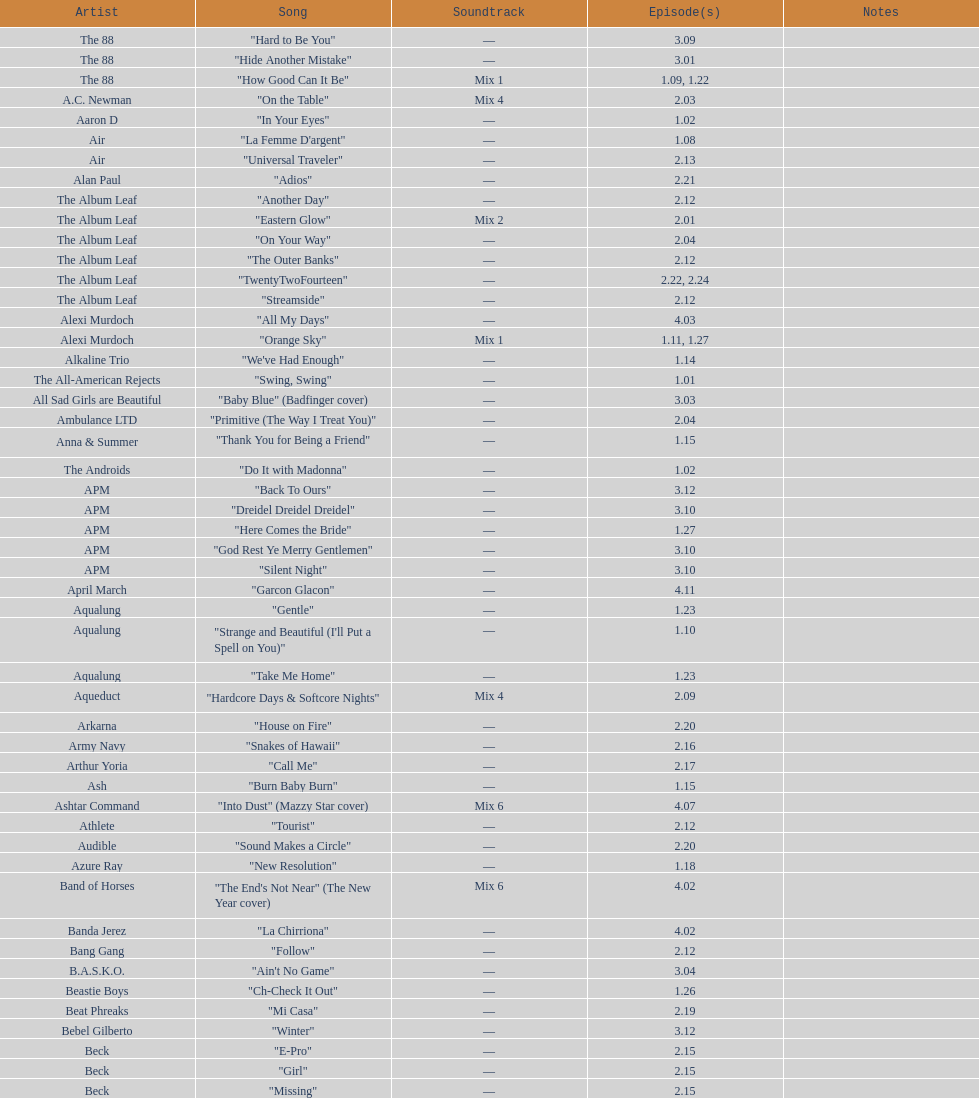00? 27. 